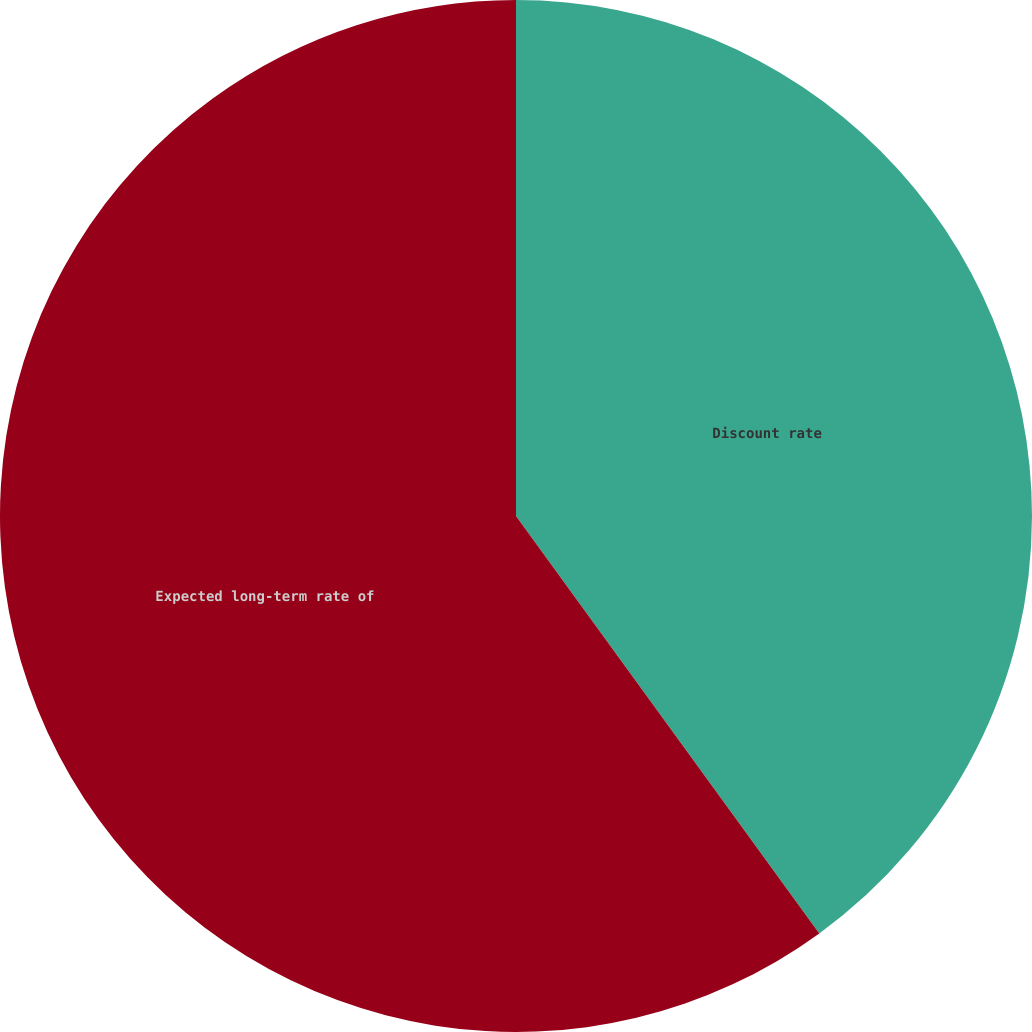<chart> <loc_0><loc_0><loc_500><loc_500><pie_chart><fcel>Discount rate<fcel>Expected long-term rate of<nl><fcel>40.0%<fcel>60.0%<nl></chart> 